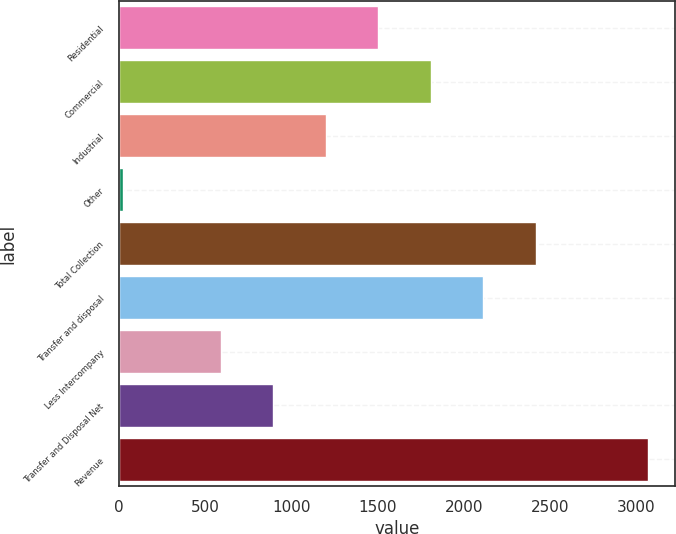Convert chart. <chart><loc_0><loc_0><loc_500><loc_500><bar_chart><fcel>Residential<fcel>Commercial<fcel>Industrial<fcel>Other<fcel>Total Collection<fcel>Transfer and disposal<fcel>Less Intercompany<fcel>Transfer and Disposal Net<fcel>Revenue<nl><fcel>1503.06<fcel>1807.88<fcel>1198.24<fcel>22.4<fcel>2417.52<fcel>2112.7<fcel>588.6<fcel>893.42<fcel>3070.6<nl></chart> 